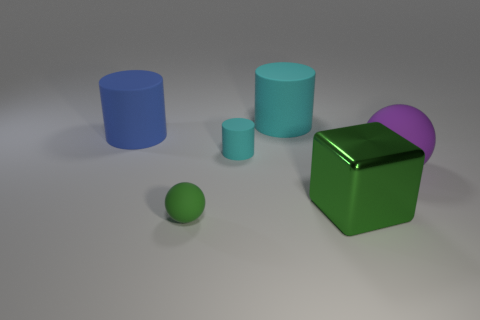There is a tiny object that is the same color as the big block; what material is it?
Ensure brevity in your answer.  Rubber. How many things are cyan things that are in front of the big cyan rubber cylinder or large rubber objects to the right of the green shiny block?
Keep it short and to the point. 2. What material is the small object that is on the right side of the matte sphere that is on the left side of the small matte cylinder on the right side of the small green matte thing?
Your response must be concise. Rubber. There is a big thing that is in front of the purple matte sphere; does it have the same color as the small matte cylinder?
Your answer should be compact. No. What is the material of the large thing that is behind the big purple rubber ball and right of the big blue rubber thing?
Offer a terse response. Rubber. Are there any green rubber things that have the same size as the green cube?
Provide a succinct answer. No. How many metallic cubes are there?
Give a very brief answer. 1. What number of big cylinders are on the right side of the green metal thing?
Your answer should be very brief. 0. Are the blue cylinder and the big green thing made of the same material?
Ensure brevity in your answer.  No. How many things are both in front of the small cyan thing and behind the small green thing?
Give a very brief answer. 2. 